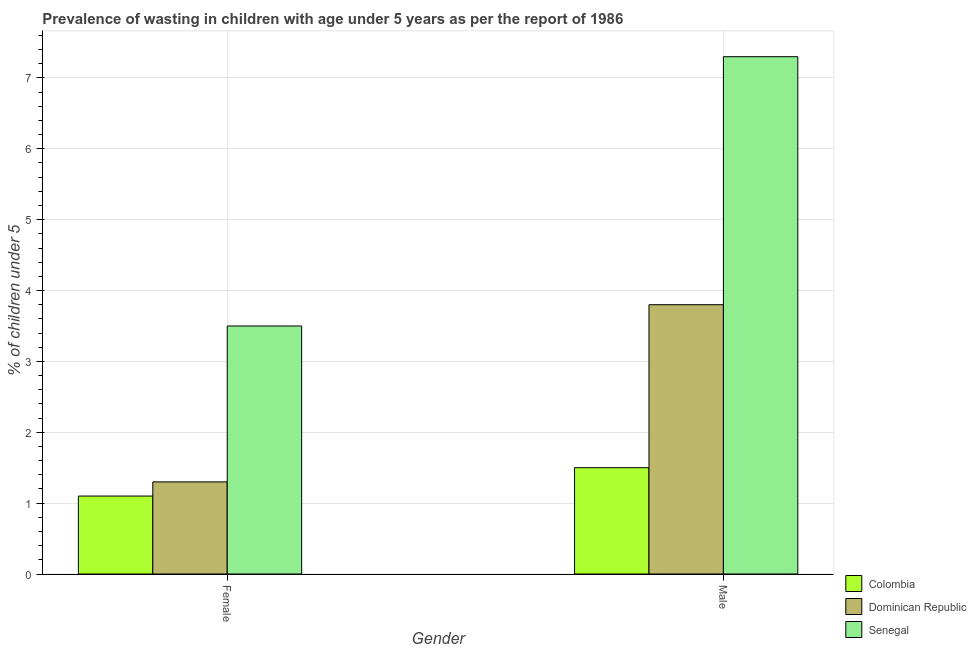How many different coloured bars are there?
Make the answer very short. 3. Are the number of bars on each tick of the X-axis equal?
Keep it short and to the point. Yes. What is the label of the 1st group of bars from the left?
Offer a terse response. Female. What is the percentage of undernourished male children in Dominican Republic?
Offer a terse response. 3.8. Across all countries, what is the maximum percentage of undernourished male children?
Your answer should be compact. 7.3. Across all countries, what is the minimum percentage of undernourished male children?
Your answer should be very brief. 1.5. In which country was the percentage of undernourished female children maximum?
Offer a terse response. Senegal. What is the total percentage of undernourished male children in the graph?
Provide a succinct answer. 12.6. What is the difference between the percentage of undernourished male children in Colombia and that in Dominican Republic?
Your answer should be very brief. -2.3. What is the difference between the percentage of undernourished male children in Dominican Republic and the percentage of undernourished female children in Senegal?
Provide a short and direct response. 0.3. What is the average percentage of undernourished female children per country?
Provide a succinct answer. 1.97. What is the difference between the percentage of undernourished female children and percentage of undernourished male children in Senegal?
Give a very brief answer. -3.8. What is the ratio of the percentage of undernourished male children in Dominican Republic to that in Colombia?
Make the answer very short. 2.53. In how many countries, is the percentage of undernourished female children greater than the average percentage of undernourished female children taken over all countries?
Make the answer very short. 1. What does the 1st bar from the right in Female represents?
Your response must be concise. Senegal. How many bars are there?
Offer a terse response. 6. Are all the bars in the graph horizontal?
Your answer should be very brief. No. Are the values on the major ticks of Y-axis written in scientific E-notation?
Your answer should be very brief. No. Does the graph contain grids?
Offer a very short reply. Yes. Where does the legend appear in the graph?
Your answer should be compact. Bottom right. What is the title of the graph?
Your answer should be very brief. Prevalence of wasting in children with age under 5 years as per the report of 1986. What is the label or title of the Y-axis?
Offer a terse response.  % of children under 5. What is the  % of children under 5 in Colombia in Female?
Your answer should be compact. 1.1. What is the  % of children under 5 of Dominican Republic in Female?
Make the answer very short. 1.3. What is the  % of children under 5 in Senegal in Female?
Give a very brief answer. 3.5. What is the  % of children under 5 in Colombia in Male?
Offer a terse response. 1.5. What is the  % of children under 5 of Dominican Republic in Male?
Your response must be concise. 3.8. What is the  % of children under 5 in Senegal in Male?
Ensure brevity in your answer.  7.3. Across all Gender, what is the maximum  % of children under 5 in Dominican Republic?
Provide a short and direct response. 3.8. Across all Gender, what is the maximum  % of children under 5 of Senegal?
Offer a very short reply. 7.3. Across all Gender, what is the minimum  % of children under 5 of Colombia?
Ensure brevity in your answer.  1.1. Across all Gender, what is the minimum  % of children under 5 of Dominican Republic?
Offer a very short reply. 1.3. What is the difference between the  % of children under 5 in Colombia in Female and the  % of children under 5 in Senegal in Male?
Make the answer very short. -6.2. What is the difference between the  % of children under 5 of Dominican Republic in Female and the  % of children under 5 of Senegal in Male?
Make the answer very short. -6. What is the average  % of children under 5 in Dominican Republic per Gender?
Make the answer very short. 2.55. What is the average  % of children under 5 in Senegal per Gender?
Make the answer very short. 5.4. What is the difference between the  % of children under 5 in Colombia and  % of children under 5 in Senegal in Female?
Provide a short and direct response. -2.4. What is the difference between the  % of children under 5 of Dominican Republic and  % of children under 5 of Senegal in Female?
Give a very brief answer. -2.2. What is the difference between the  % of children under 5 of Colombia and  % of children under 5 of Senegal in Male?
Your answer should be compact. -5.8. What is the ratio of the  % of children under 5 of Colombia in Female to that in Male?
Your response must be concise. 0.73. What is the ratio of the  % of children under 5 of Dominican Republic in Female to that in Male?
Offer a very short reply. 0.34. What is the ratio of the  % of children under 5 in Senegal in Female to that in Male?
Make the answer very short. 0.48. What is the difference between the highest and the second highest  % of children under 5 of Dominican Republic?
Your answer should be very brief. 2.5. What is the difference between the highest and the lowest  % of children under 5 in Colombia?
Provide a short and direct response. 0.4. What is the difference between the highest and the lowest  % of children under 5 of Dominican Republic?
Your answer should be very brief. 2.5. 